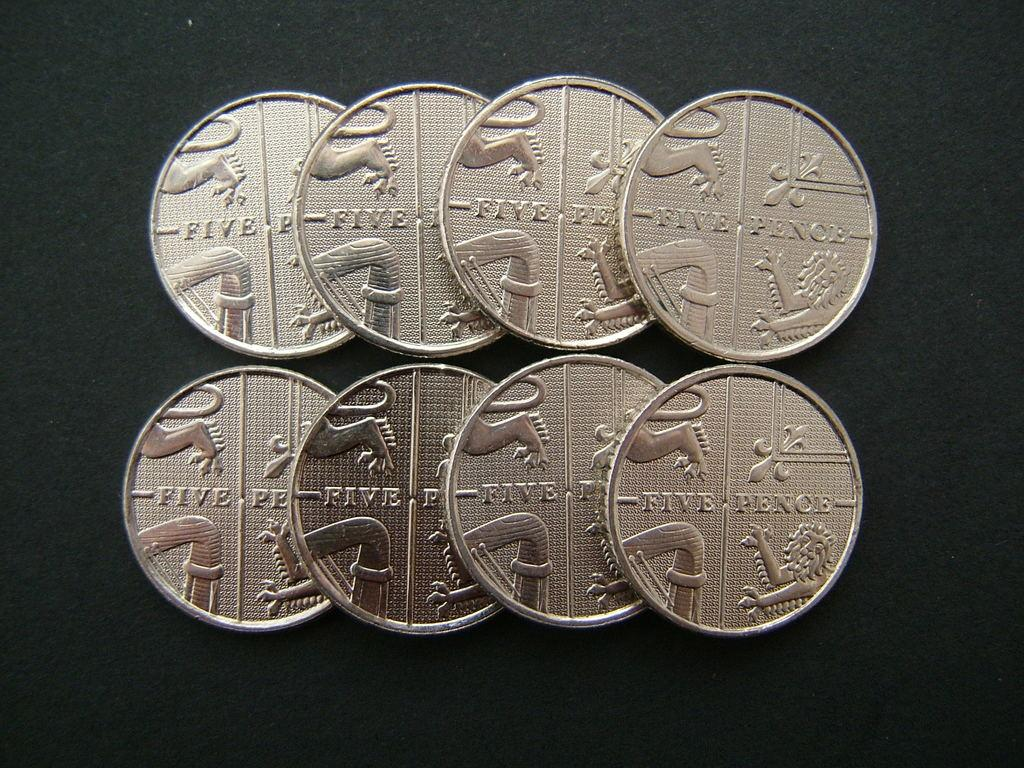<image>
Create a compact narrative representing the image presented. eight five pence coins on a black background 